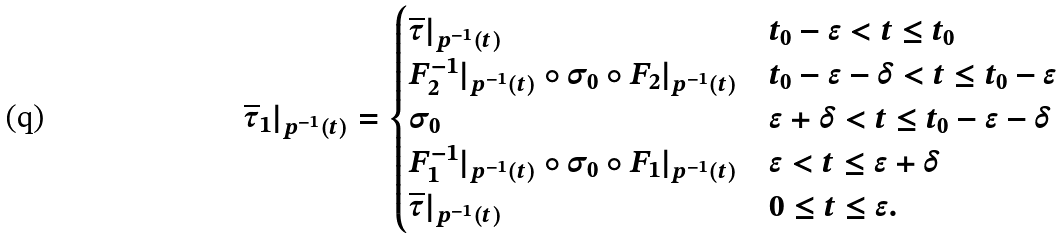<formula> <loc_0><loc_0><loc_500><loc_500>\overline { \tau } _ { 1 } | _ { p ^ { - 1 } ( t ) } = \begin{cases} \overline { \tau } | _ { p ^ { - 1 } ( t ) } & t _ { 0 } - \epsilon < t \leq t _ { 0 } \\ F _ { 2 } ^ { - 1 } | _ { p ^ { - 1 } ( t ) } \circ \sigma _ { 0 } \circ F _ { 2 } | _ { p ^ { - 1 } ( t ) } & t _ { 0 } - \epsilon - \delta < t \leq t _ { 0 } - \epsilon \\ \sigma _ { 0 } & \epsilon + \delta < t \leq t _ { 0 } - \epsilon - \delta \\ F _ { 1 } ^ { - 1 } | _ { p ^ { - 1 } ( t ) } \circ \sigma _ { 0 } \circ F _ { 1 } | _ { p ^ { - 1 } ( t ) } & \epsilon < t \leq \epsilon + \delta \\ \overline { \tau } | _ { p ^ { - 1 } ( t ) } & 0 \leq t \leq \epsilon . \end{cases}</formula> 